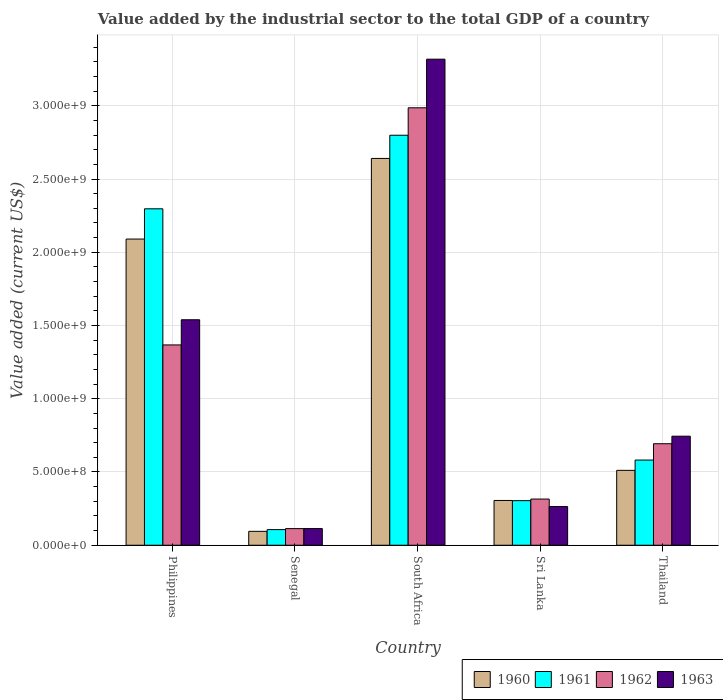Are the number of bars per tick equal to the number of legend labels?
Your answer should be compact. Yes. Are the number of bars on each tick of the X-axis equal?
Your answer should be very brief. Yes. How many bars are there on the 2nd tick from the left?
Your answer should be compact. 4. How many bars are there on the 3rd tick from the right?
Provide a succinct answer. 4. What is the label of the 2nd group of bars from the left?
Provide a short and direct response. Senegal. What is the value added by the industrial sector to the total GDP in 1963 in Thailand?
Make the answer very short. 7.44e+08. Across all countries, what is the maximum value added by the industrial sector to the total GDP in 1962?
Your answer should be very brief. 2.99e+09. Across all countries, what is the minimum value added by the industrial sector to the total GDP in 1963?
Give a very brief answer. 1.14e+08. In which country was the value added by the industrial sector to the total GDP in 1960 maximum?
Give a very brief answer. South Africa. In which country was the value added by the industrial sector to the total GDP in 1963 minimum?
Keep it short and to the point. Senegal. What is the total value added by the industrial sector to the total GDP in 1963 in the graph?
Offer a terse response. 5.98e+09. What is the difference between the value added by the industrial sector to the total GDP in 1961 in Philippines and that in Thailand?
Ensure brevity in your answer.  1.72e+09. What is the difference between the value added by the industrial sector to the total GDP in 1962 in Philippines and the value added by the industrial sector to the total GDP in 1960 in Thailand?
Give a very brief answer. 8.56e+08. What is the average value added by the industrial sector to the total GDP in 1962 per country?
Ensure brevity in your answer.  1.10e+09. What is the difference between the value added by the industrial sector to the total GDP of/in 1961 and value added by the industrial sector to the total GDP of/in 1962 in Philippines?
Your response must be concise. 9.29e+08. In how many countries, is the value added by the industrial sector to the total GDP in 1962 greater than 2800000000 US$?
Your answer should be compact. 1. What is the ratio of the value added by the industrial sector to the total GDP in 1960 in Senegal to that in Thailand?
Make the answer very short. 0.19. Is the difference between the value added by the industrial sector to the total GDP in 1961 in Senegal and Sri Lanka greater than the difference between the value added by the industrial sector to the total GDP in 1962 in Senegal and Sri Lanka?
Provide a short and direct response. Yes. What is the difference between the highest and the second highest value added by the industrial sector to the total GDP in 1963?
Keep it short and to the point. 1.78e+09. What is the difference between the highest and the lowest value added by the industrial sector to the total GDP in 1961?
Your answer should be very brief. 2.69e+09. In how many countries, is the value added by the industrial sector to the total GDP in 1960 greater than the average value added by the industrial sector to the total GDP in 1960 taken over all countries?
Offer a terse response. 2. Is it the case that in every country, the sum of the value added by the industrial sector to the total GDP in 1960 and value added by the industrial sector to the total GDP in 1962 is greater than the sum of value added by the industrial sector to the total GDP in 1963 and value added by the industrial sector to the total GDP in 1961?
Make the answer very short. No. What does the 4th bar from the left in Senegal represents?
Offer a terse response. 1963. What does the 4th bar from the right in Sri Lanka represents?
Make the answer very short. 1960. Is it the case that in every country, the sum of the value added by the industrial sector to the total GDP in 1961 and value added by the industrial sector to the total GDP in 1962 is greater than the value added by the industrial sector to the total GDP in 1963?
Make the answer very short. Yes. Does the graph contain grids?
Provide a succinct answer. Yes. Where does the legend appear in the graph?
Keep it short and to the point. Bottom right. How many legend labels are there?
Your answer should be compact. 4. How are the legend labels stacked?
Provide a succinct answer. Horizontal. What is the title of the graph?
Make the answer very short. Value added by the industrial sector to the total GDP of a country. What is the label or title of the Y-axis?
Make the answer very short. Value added (current US$). What is the Value added (current US$) of 1960 in Philippines?
Give a very brief answer. 2.09e+09. What is the Value added (current US$) of 1961 in Philippines?
Make the answer very short. 2.30e+09. What is the Value added (current US$) in 1962 in Philippines?
Give a very brief answer. 1.37e+09. What is the Value added (current US$) of 1963 in Philippines?
Ensure brevity in your answer.  1.54e+09. What is the Value added (current US$) in 1960 in Senegal?
Your answer should be very brief. 9.49e+07. What is the Value added (current US$) in 1961 in Senegal?
Ensure brevity in your answer.  1.07e+08. What is the Value added (current US$) of 1962 in Senegal?
Keep it short and to the point. 1.13e+08. What is the Value added (current US$) of 1963 in Senegal?
Ensure brevity in your answer.  1.14e+08. What is the Value added (current US$) of 1960 in South Africa?
Make the answer very short. 2.64e+09. What is the Value added (current US$) of 1961 in South Africa?
Ensure brevity in your answer.  2.80e+09. What is the Value added (current US$) of 1962 in South Africa?
Your answer should be very brief. 2.99e+09. What is the Value added (current US$) in 1963 in South Africa?
Provide a short and direct response. 3.32e+09. What is the Value added (current US$) of 1960 in Sri Lanka?
Your answer should be very brief. 3.06e+08. What is the Value added (current US$) in 1961 in Sri Lanka?
Your response must be concise. 3.04e+08. What is the Value added (current US$) of 1962 in Sri Lanka?
Ensure brevity in your answer.  3.15e+08. What is the Value added (current US$) of 1963 in Sri Lanka?
Give a very brief answer. 2.64e+08. What is the Value added (current US$) in 1960 in Thailand?
Your answer should be very brief. 5.11e+08. What is the Value added (current US$) of 1961 in Thailand?
Ensure brevity in your answer.  5.81e+08. What is the Value added (current US$) of 1962 in Thailand?
Your answer should be compact. 6.93e+08. What is the Value added (current US$) of 1963 in Thailand?
Give a very brief answer. 7.44e+08. Across all countries, what is the maximum Value added (current US$) in 1960?
Your answer should be compact. 2.64e+09. Across all countries, what is the maximum Value added (current US$) of 1961?
Offer a terse response. 2.80e+09. Across all countries, what is the maximum Value added (current US$) in 1962?
Provide a short and direct response. 2.99e+09. Across all countries, what is the maximum Value added (current US$) in 1963?
Your answer should be very brief. 3.32e+09. Across all countries, what is the minimum Value added (current US$) in 1960?
Your answer should be very brief. 9.49e+07. Across all countries, what is the minimum Value added (current US$) of 1961?
Keep it short and to the point. 1.07e+08. Across all countries, what is the minimum Value added (current US$) of 1962?
Make the answer very short. 1.13e+08. Across all countries, what is the minimum Value added (current US$) of 1963?
Ensure brevity in your answer.  1.14e+08. What is the total Value added (current US$) in 1960 in the graph?
Your answer should be compact. 5.64e+09. What is the total Value added (current US$) of 1961 in the graph?
Your answer should be very brief. 6.09e+09. What is the total Value added (current US$) of 1962 in the graph?
Offer a terse response. 5.48e+09. What is the total Value added (current US$) in 1963 in the graph?
Offer a very short reply. 5.98e+09. What is the difference between the Value added (current US$) in 1960 in Philippines and that in Senegal?
Keep it short and to the point. 2.00e+09. What is the difference between the Value added (current US$) of 1961 in Philippines and that in Senegal?
Offer a terse response. 2.19e+09. What is the difference between the Value added (current US$) of 1962 in Philippines and that in Senegal?
Your response must be concise. 1.25e+09. What is the difference between the Value added (current US$) of 1963 in Philippines and that in Senegal?
Your response must be concise. 1.43e+09. What is the difference between the Value added (current US$) of 1960 in Philippines and that in South Africa?
Your answer should be very brief. -5.50e+08. What is the difference between the Value added (current US$) in 1961 in Philippines and that in South Africa?
Ensure brevity in your answer.  -5.02e+08. What is the difference between the Value added (current US$) in 1962 in Philippines and that in South Africa?
Your answer should be compact. -1.62e+09. What is the difference between the Value added (current US$) of 1963 in Philippines and that in South Africa?
Offer a terse response. -1.78e+09. What is the difference between the Value added (current US$) in 1960 in Philippines and that in Sri Lanka?
Offer a very short reply. 1.78e+09. What is the difference between the Value added (current US$) of 1961 in Philippines and that in Sri Lanka?
Keep it short and to the point. 1.99e+09. What is the difference between the Value added (current US$) in 1962 in Philippines and that in Sri Lanka?
Give a very brief answer. 1.05e+09. What is the difference between the Value added (current US$) of 1963 in Philippines and that in Sri Lanka?
Keep it short and to the point. 1.28e+09. What is the difference between the Value added (current US$) in 1960 in Philippines and that in Thailand?
Offer a very short reply. 1.58e+09. What is the difference between the Value added (current US$) of 1961 in Philippines and that in Thailand?
Offer a terse response. 1.72e+09. What is the difference between the Value added (current US$) of 1962 in Philippines and that in Thailand?
Offer a terse response. 6.74e+08. What is the difference between the Value added (current US$) of 1963 in Philippines and that in Thailand?
Make the answer very short. 7.95e+08. What is the difference between the Value added (current US$) in 1960 in Senegal and that in South Africa?
Provide a short and direct response. -2.55e+09. What is the difference between the Value added (current US$) of 1961 in Senegal and that in South Africa?
Your answer should be very brief. -2.69e+09. What is the difference between the Value added (current US$) in 1962 in Senegal and that in South Africa?
Provide a short and direct response. -2.87e+09. What is the difference between the Value added (current US$) in 1963 in Senegal and that in South Africa?
Offer a terse response. -3.20e+09. What is the difference between the Value added (current US$) in 1960 in Senegal and that in Sri Lanka?
Your response must be concise. -2.11e+08. What is the difference between the Value added (current US$) in 1961 in Senegal and that in Sri Lanka?
Provide a succinct answer. -1.98e+08. What is the difference between the Value added (current US$) in 1962 in Senegal and that in Sri Lanka?
Ensure brevity in your answer.  -2.02e+08. What is the difference between the Value added (current US$) of 1963 in Senegal and that in Sri Lanka?
Give a very brief answer. -1.50e+08. What is the difference between the Value added (current US$) of 1960 in Senegal and that in Thailand?
Your response must be concise. -4.16e+08. What is the difference between the Value added (current US$) in 1961 in Senegal and that in Thailand?
Ensure brevity in your answer.  -4.75e+08. What is the difference between the Value added (current US$) in 1962 in Senegal and that in Thailand?
Keep it short and to the point. -5.79e+08. What is the difference between the Value added (current US$) in 1963 in Senegal and that in Thailand?
Make the answer very short. -6.31e+08. What is the difference between the Value added (current US$) of 1960 in South Africa and that in Sri Lanka?
Offer a terse response. 2.33e+09. What is the difference between the Value added (current US$) of 1961 in South Africa and that in Sri Lanka?
Your response must be concise. 2.49e+09. What is the difference between the Value added (current US$) in 1962 in South Africa and that in Sri Lanka?
Your answer should be compact. 2.67e+09. What is the difference between the Value added (current US$) of 1963 in South Africa and that in Sri Lanka?
Your answer should be very brief. 3.05e+09. What is the difference between the Value added (current US$) of 1960 in South Africa and that in Thailand?
Give a very brief answer. 2.13e+09. What is the difference between the Value added (current US$) of 1961 in South Africa and that in Thailand?
Your answer should be very brief. 2.22e+09. What is the difference between the Value added (current US$) in 1962 in South Africa and that in Thailand?
Give a very brief answer. 2.29e+09. What is the difference between the Value added (current US$) of 1963 in South Africa and that in Thailand?
Offer a very short reply. 2.57e+09. What is the difference between the Value added (current US$) of 1960 in Sri Lanka and that in Thailand?
Provide a succinct answer. -2.06e+08. What is the difference between the Value added (current US$) of 1961 in Sri Lanka and that in Thailand?
Offer a terse response. -2.77e+08. What is the difference between the Value added (current US$) in 1962 in Sri Lanka and that in Thailand?
Your response must be concise. -3.78e+08. What is the difference between the Value added (current US$) of 1963 in Sri Lanka and that in Thailand?
Offer a very short reply. -4.80e+08. What is the difference between the Value added (current US$) in 1960 in Philippines and the Value added (current US$) in 1961 in Senegal?
Your response must be concise. 1.98e+09. What is the difference between the Value added (current US$) of 1960 in Philippines and the Value added (current US$) of 1962 in Senegal?
Your answer should be very brief. 1.98e+09. What is the difference between the Value added (current US$) in 1960 in Philippines and the Value added (current US$) in 1963 in Senegal?
Provide a short and direct response. 1.98e+09. What is the difference between the Value added (current US$) in 1961 in Philippines and the Value added (current US$) in 1962 in Senegal?
Ensure brevity in your answer.  2.18e+09. What is the difference between the Value added (current US$) of 1961 in Philippines and the Value added (current US$) of 1963 in Senegal?
Offer a very short reply. 2.18e+09. What is the difference between the Value added (current US$) of 1962 in Philippines and the Value added (current US$) of 1963 in Senegal?
Give a very brief answer. 1.25e+09. What is the difference between the Value added (current US$) of 1960 in Philippines and the Value added (current US$) of 1961 in South Africa?
Offer a very short reply. -7.09e+08. What is the difference between the Value added (current US$) of 1960 in Philippines and the Value added (current US$) of 1962 in South Africa?
Your answer should be compact. -8.96e+08. What is the difference between the Value added (current US$) in 1960 in Philippines and the Value added (current US$) in 1963 in South Africa?
Keep it short and to the point. -1.23e+09. What is the difference between the Value added (current US$) of 1961 in Philippines and the Value added (current US$) of 1962 in South Africa?
Your answer should be compact. -6.90e+08. What is the difference between the Value added (current US$) of 1961 in Philippines and the Value added (current US$) of 1963 in South Africa?
Keep it short and to the point. -1.02e+09. What is the difference between the Value added (current US$) of 1962 in Philippines and the Value added (current US$) of 1963 in South Africa?
Ensure brevity in your answer.  -1.95e+09. What is the difference between the Value added (current US$) of 1960 in Philippines and the Value added (current US$) of 1961 in Sri Lanka?
Give a very brief answer. 1.79e+09. What is the difference between the Value added (current US$) of 1960 in Philippines and the Value added (current US$) of 1962 in Sri Lanka?
Make the answer very short. 1.77e+09. What is the difference between the Value added (current US$) of 1960 in Philippines and the Value added (current US$) of 1963 in Sri Lanka?
Give a very brief answer. 1.83e+09. What is the difference between the Value added (current US$) of 1961 in Philippines and the Value added (current US$) of 1962 in Sri Lanka?
Give a very brief answer. 1.98e+09. What is the difference between the Value added (current US$) of 1961 in Philippines and the Value added (current US$) of 1963 in Sri Lanka?
Keep it short and to the point. 2.03e+09. What is the difference between the Value added (current US$) in 1962 in Philippines and the Value added (current US$) in 1963 in Sri Lanka?
Give a very brief answer. 1.10e+09. What is the difference between the Value added (current US$) of 1960 in Philippines and the Value added (current US$) of 1961 in Thailand?
Ensure brevity in your answer.  1.51e+09. What is the difference between the Value added (current US$) of 1960 in Philippines and the Value added (current US$) of 1962 in Thailand?
Your answer should be compact. 1.40e+09. What is the difference between the Value added (current US$) in 1960 in Philippines and the Value added (current US$) in 1963 in Thailand?
Your answer should be very brief. 1.35e+09. What is the difference between the Value added (current US$) of 1961 in Philippines and the Value added (current US$) of 1962 in Thailand?
Your answer should be very brief. 1.60e+09. What is the difference between the Value added (current US$) of 1961 in Philippines and the Value added (current US$) of 1963 in Thailand?
Give a very brief answer. 1.55e+09. What is the difference between the Value added (current US$) in 1962 in Philippines and the Value added (current US$) in 1963 in Thailand?
Offer a very short reply. 6.23e+08. What is the difference between the Value added (current US$) in 1960 in Senegal and the Value added (current US$) in 1961 in South Africa?
Give a very brief answer. -2.70e+09. What is the difference between the Value added (current US$) of 1960 in Senegal and the Value added (current US$) of 1962 in South Africa?
Provide a succinct answer. -2.89e+09. What is the difference between the Value added (current US$) of 1960 in Senegal and the Value added (current US$) of 1963 in South Africa?
Give a very brief answer. -3.22e+09. What is the difference between the Value added (current US$) of 1961 in Senegal and the Value added (current US$) of 1962 in South Africa?
Make the answer very short. -2.88e+09. What is the difference between the Value added (current US$) of 1961 in Senegal and the Value added (current US$) of 1963 in South Africa?
Your answer should be very brief. -3.21e+09. What is the difference between the Value added (current US$) in 1962 in Senegal and the Value added (current US$) in 1963 in South Africa?
Offer a terse response. -3.20e+09. What is the difference between the Value added (current US$) in 1960 in Senegal and the Value added (current US$) in 1961 in Sri Lanka?
Your answer should be very brief. -2.10e+08. What is the difference between the Value added (current US$) in 1960 in Senegal and the Value added (current US$) in 1962 in Sri Lanka?
Your response must be concise. -2.20e+08. What is the difference between the Value added (current US$) of 1960 in Senegal and the Value added (current US$) of 1963 in Sri Lanka?
Provide a succinct answer. -1.69e+08. What is the difference between the Value added (current US$) in 1961 in Senegal and the Value added (current US$) in 1962 in Sri Lanka?
Your answer should be very brief. -2.08e+08. What is the difference between the Value added (current US$) in 1961 in Senegal and the Value added (current US$) in 1963 in Sri Lanka?
Make the answer very short. -1.57e+08. What is the difference between the Value added (current US$) in 1962 in Senegal and the Value added (current US$) in 1963 in Sri Lanka?
Give a very brief answer. -1.51e+08. What is the difference between the Value added (current US$) of 1960 in Senegal and the Value added (current US$) of 1961 in Thailand?
Your answer should be very brief. -4.87e+08. What is the difference between the Value added (current US$) in 1960 in Senegal and the Value added (current US$) in 1962 in Thailand?
Make the answer very short. -5.98e+08. What is the difference between the Value added (current US$) in 1960 in Senegal and the Value added (current US$) in 1963 in Thailand?
Ensure brevity in your answer.  -6.50e+08. What is the difference between the Value added (current US$) of 1961 in Senegal and the Value added (current US$) of 1962 in Thailand?
Offer a terse response. -5.86e+08. What is the difference between the Value added (current US$) in 1961 in Senegal and the Value added (current US$) in 1963 in Thailand?
Offer a terse response. -6.38e+08. What is the difference between the Value added (current US$) of 1962 in Senegal and the Value added (current US$) of 1963 in Thailand?
Ensure brevity in your answer.  -6.31e+08. What is the difference between the Value added (current US$) of 1960 in South Africa and the Value added (current US$) of 1961 in Sri Lanka?
Keep it short and to the point. 2.34e+09. What is the difference between the Value added (current US$) of 1960 in South Africa and the Value added (current US$) of 1962 in Sri Lanka?
Make the answer very short. 2.33e+09. What is the difference between the Value added (current US$) in 1960 in South Africa and the Value added (current US$) in 1963 in Sri Lanka?
Provide a succinct answer. 2.38e+09. What is the difference between the Value added (current US$) of 1961 in South Africa and the Value added (current US$) of 1962 in Sri Lanka?
Provide a succinct answer. 2.48e+09. What is the difference between the Value added (current US$) in 1961 in South Africa and the Value added (current US$) in 1963 in Sri Lanka?
Your answer should be compact. 2.53e+09. What is the difference between the Value added (current US$) of 1962 in South Africa and the Value added (current US$) of 1963 in Sri Lanka?
Your answer should be compact. 2.72e+09. What is the difference between the Value added (current US$) of 1960 in South Africa and the Value added (current US$) of 1961 in Thailand?
Make the answer very short. 2.06e+09. What is the difference between the Value added (current US$) in 1960 in South Africa and the Value added (current US$) in 1962 in Thailand?
Offer a very short reply. 1.95e+09. What is the difference between the Value added (current US$) of 1960 in South Africa and the Value added (current US$) of 1963 in Thailand?
Provide a succinct answer. 1.90e+09. What is the difference between the Value added (current US$) of 1961 in South Africa and the Value added (current US$) of 1962 in Thailand?
Ensure brevity in your answer.  2.11e+09. What is the difference between the Value added (current US$) in 1961 in South Africa and the Value added (current US$) in 1963 in Thailand?
Offer a very short reply. 2.05e+09. What is the difference between the Value added (current US$) in 1962 in South Africa and the Value added (current US$) in 1963 in Thailand?
Keep it short and to the point. 2.24e+09. What is the difference between the Value added (current US$) of 1960 in Sri Lanka and the Value added (current US$) of 1961 in Thailand?
Make the answer very short. -2.76e+08. What is the difference between the Value added (current US$) of 1960 in Sri Lanka and the Value added (current US$) of 1962 in Thailand?
Keep it short and to the point. -3.87e+08. What is the difference between the Value added (current US$) of 1960 in Sri Lanka and the Value added (current US$) of 1963 in Thailand?
Make the answer very short. -4.39e+08. What is the difference between the Value added (current US$) of 1961 in Sri Lanka and the Value added (current US$) of 1962 in Thailand?
Make the answer very short. -3.89e+08. What is the difference between the Value added (current US$) in 1961 in Sri Lanka and the Value added (current US$) in 1963 in Thailand?
Your answer should be very brief. -4.40e+08. What is the difference between the Value added (current US$) of 1962 in Sri Lanka and the Value added (current US$) of 1963 in Thailand?
Provide a short and direct response. -4.29e+08. What is the average Value added (current US$) in 1960 per country?
Offer a very short reply. 1.13e+09. What is the average Value added (current US$) in 1961 per country?
Your response must be concise. 1.22e+09. What is the average Value added (current US$) of 1962 per country?
Provide a short and direct response. 1.10e+09. What is the average Value added (current US$) in 1963 per country?
Keep it short and to the point. 1.20e+09. What is the difference between the Value added (current US$) in 1960 and Value added (current US$) in 1961 in Philippines?
Your answer should be compact. -2.07e+08. What is the difference between the Value added (current US$) of 1960 and Value added (current US$) of 1962 in Philippines?
Your answer should be very brief. 7.23e+08. What is the difference between the Value added (current US$) in 1960 and Value added (current US$) in 1963 in Philippines?
Keep it short and to the point. 5.51e+08. What is the difference between the Value added (current US$) in 1961 and Value added (current US$) in 1962 in Philippines?
Your answer should be very brief. 9.29e+08. What is the difference between the Value added (current US$) in 1961 and Value added (current US$) in 1963 in Philippines?
Your answer should be compact. 7.57e+08. What is the difference between the Value added (current US$) in 1962 and Value added (current US$) in 1963 in Philippines?
Your answer should be compact. -1.72e+08. What is the difference between the Value added (current US$) in 1960 and Value added (current US$) in 1961 in Senegal?
Provide a succinct answer. -1.19e+07. What is the difference between the Value added (current US$) in 1960 and Value added (current US$) in 1962 in Senegal?
Ensure brevity in your answer.  -1.86e+07. What is the difference between the Value added (current US$) of 1960 and Value added (current US$) of 1963 in Senegal?
Offer a terse response. -1.91e+07. What is the difference between the Value added (current US$) of 1961 and Value added (current US$) of 1962 in Senegal?
Provide a succinct answer. -6.73e+06. What is the difference between the Value added (current US$) of 1961 and Value added (current US$) of 1963 in Senegal?
Provide a succinct answer. -7.17e+06. What is the difference between the Value added (current US$) of 1962 and Value added (current US$) of 1963 in Senegal?
Give a very brief answer. -4.40e+05. What is the difference between the Value added (current US$) of 1960 and Value added (current US$) of 1961 in South Africa?
Your response must be concise. -1.58e+08. What is the difference between the Value added (current US$) of 1960 and Value added (current US$) of 1962 in South Africa?
Make the answer very short. -3.46e+08. What is the difference between the Value added (current US$) in 1960 and Value added (current US$) in 1963 in South Africa?
Your answer should be very brief. -6.78e+08. What is the difference between the Value added (current US$) of 1961 and Value added (current US$) of 1962 in South Africa?
Give a very brief answer. -1.87e+08. What is the difference between the Value added (current US$) in 1961 and Value added (current US$) in 1963 in South Africa?
Give a very brief answer. -5.19e+08. What is the difference between the Value added (current US$) of 1962 and Value added (current US$) of 1963 in South Africa?
Give a very brief answer. -3.32e+08. What is the difference between the Value added (current US$) in 1960 and Value added (current US$) in 1961 in Sri Lanka?
Your response must be concise. 1.26e+06. What is the difference between the Value added (current US$) in 1960 and Value added (current US$) in 1962 in Sri Lanka?
Your response must be concise. -9.55e+06. What is the difference between the Value added (current US$) of 1960 and Value added (current US$) of 1963 in Sri Lanka?
Make the answer very short. 4.16e+07. What is the difference between the Value added (current US$) in 1961 and Value added (current US$) in 1962 in Sri Lanka?
Provide a succinct answer. -1.08e+07. What is the difference between the Value added (current US$) in 1961 and Value added (current US$) in 1963 in Sri Lanka?
Your answer should be compact. 4.04e+07. What is the difference between the Value added (current US$) of 1962 and Value added (current US$) of 1963 in Sri Lanka?
Keep it short and to the point. 5.12e+07. What is the difference between the Value added (current US$) of 1960 and Value added (current US$) of 1961 in Thailand?
Offer a very short reply. -7.03e+07. What is the difference between the Value added (current US$) of 1960 and Value added (current US$) of 1962 in Thailand?
Ensure brevity in your answer.  -1.82e+08. What is the difference between the Value added (current US$) in 1960 and Value added (current US$) in 1963 in Thailand?
Your answer should be compact. -2.33e+08. What is the difference between the Value added (current US$) of 1961 and Value added (current US$) of 1962 in Thailand?
Your response must be concise. -1.12e+08. What is the difference between the Value added (current US$) of 1961 and Value added (current US$) of 1963 in Thailand?
Give a very brief answer. -1.63e+08. What is the difference between the Value added (current US$) in 1962 and Value added (current US$) in 1963 in Thailand?
Give a very brief answer. -5.15e+07. What is the ratio of the Value added (current US$) in 1960 in Philippines to that in Senegal?
Your response must be concise. 22.03. What is the ratio of the Value added (current US$) of 1961 in Philippines to that in Senegal?
Your response must be concise. 21.51. What is the ratio of the Value added (current US$) in 1962 in Philippines to that in Senegal?
Offer a terse response. 12.05. What is the ratio of the Value added (current US$) of 1963 in Philippines to that in Senegal?
Provide a succinct answer. 13.51. What is the ratio of the Value added (current US$) in 1960 in Philippines to that in South Africa?
Ensure brevity in your answer.  0.79. What is the ratio of the Value added (current US$) in 1961 in Philippines to that in South Africa?
Provide a short and direct response. 0.82. What is the ratio of the Value added (current US$) of 1962 in Philippines to that in South Africa?
Provide a short and direct response. 0.46. What is the ratio of the Value added (current US$) of 1963 in Philippines to that in South Africa?
Offer a very short reply. 0.46. What is the ratio of the Value added (current US$) in 1960 in Philippines to that in Sri Lanka?
Give a very brief answer. 6.84. What is the ratio of the Value added (current US$) in 1961 in Philippines to that in Sri Lanka?
Your answer should be compact. 7.54. What is the ratio of the Value added (current US$) in 1962 in Philippines to that in Sri Lanka?
Your response must be concise. 4.34. What is the ratio of the Value added (current US$) in 1963 in Philippines to that in Sri Lanka?
Offer a very short reply. 5.83. What is the ratio of the Value added (current US$) in 1960 in Philippines to that in Thailand?
Ensure brevity in your answer.  4.09. What is the ratio of the Value added (current US$) of 1961 in Philippines to that in Thailand?
Your answer should be very brief. 3.95. What is the ratio of the Value added (current US$) in 1962 in Philippines to that in Thailand?
Your answer should be compact. 1.97. What is the ratio of the Value added (current US$) of 1963 in Philippines to that in Thailand?
Make the answer very short. 2.07. What is the ratio of the Value added (current US$) of 1960 in Senegal to that in South Africa?
Keep it short and to the point. 0.04. What is the ratio of the Value added (current US$) of 1961 in Senegal to that in South Africa?
Your answer should be very brief. 0.04. What is the ratio of the Value added (current US$) in 1962 in Senegal to that in South Africa?
Your answer should be very brief. 0.04. What is the ratio of the Value added (current US$) of 1963 in Senegal to that in South Africa?
Make the answer very short. 0.03. What is the ratio of the Value added (current US$) in 1960 in Senegal to that in Sri Lanka?
Provide a short and direct response. 0.31. What is the ratio of the Value added (current US$) in 1961 in Senegal to that in Sri Lanka?
Your response must be concise. 0.35. What is the ratio of the Value added (current US$) of 1962 in Senegal to that in Sri Lanka?
Provide a short and direct response. 0.36. What is the ratio of the Value added (current US$) of 1963 in Senegal to that in Sri Lanka?
Give a very brief answer. 0.43. What is the ratio of the Value added (current US$) of 1960 in Senegal to that in Thailand?
Keep it short and to the point. 0.19. What is the ratio of the Value added (current US$) in 1961 in Senegal to that in Thailand?
Your answer should be very brief. 0.18. What is the ratio of the Value added (current US$) of 1962 in Senegal to that in Thailand?
Keep it short and to the point. 0.16. What is the ratio of the Value added (current US$) in 1963 in Senegal to that in Thailand?
Give a very brief answer. 0.15. What is the ratio of the Value added (current US$) of 1960 in South Africa to that in Sri Lanka?
Offer a terse response. 8.64. What is the ratio of the Value added (current US$) in 1961 in South Africa to that in Sri Lanka?
Make the answer very short. 9.19. What is the ratio of the Value added (current US$) in 1962 in South Africa to that in Sri Lanka?
Offer a very short reply. 9.47. What is the ratio of the Value added (current US$) of 1963 in South Africa to that in Sri Lanka?
Your response must be concise. 12.57. What is the ratio of the Value added (current US$) of 1960 in South Africa to that in Thailand?
Give a very brief answer. 5.17. What is the ratio of the Value added (current US$) of 1961 in South Africa to that in Thailand?
Keep it short and to the point. 4.81. What is the ratio of the Value added (current US$) of 1962 in South Africa to that in Thailand?
Your response must be concise. 4.31. What is the ratio of the Value added (current US$) in 1963 in South Africa to that in Thailand?
Provide a short and direct response. 4.46. What is the ratio of the Value added (current US$) in 1960 in Sri Lanka to that in Thailand?
Your answer should be compact. 0.6. What is the ratio of the Value added (current US$) in 1961 in Sri Lanka to that in Thailand?
Your response must be concise. 0.52. What is the ratio of the Value added (current US$) in 1962 in Sri Lanka to that in Thailand?
Offer a very short reply. 0.45. What is the ratio of the Value added (current US$) of 1963 in Sri Lanka to that in Thailand?
Provide a succinct answer. 0.35. What is the difference between the highest and the second highest Value added (current US$) of 1960?
Keep it short and to the point. 5.50e+08. What is the difference between the highest and the second highest Value added (current US$) in 1961?
Your answer should be very brief. 5.02e+08. What is the difference between the highest and the second highest Value added (current US$) of 1962?
Make the answer very short. 1.62e+09. What is the difference between the highest and the second highest Value added (current US$) of 1963?
Give a very brief answer. 1.78e+09. What is the difference between the highest and the lowest Value added (current US$) in 1960?
Provide a short and direct response. 2.55e+09. What is the difference between the highest and the lowest Value added (current US$) of 1961?
Provide a succinct answer. 2.69e+09. What is the difference between the highest and the lowest Value added (current US$) in 1962?
Provide a succinct answer. 2.87e+09. What is the difference between the highest and the lowest Value added (current US$) of 1963?
Keep it short and to the point. 3.20e+09. 